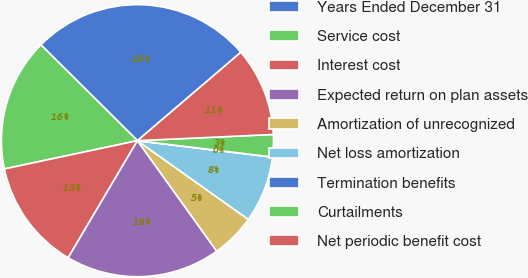Convert chart to OTSL. <chart><loc_0><loc_0><loc_500><loc_500><pie_chart><fcel>Years Ended December 31<fcel>Service cost<fcel>Interest cost<fcel>Expected return on plan assets<fcel>Amortization of unrecognized<fcel>Net loss amortization<fcel>Termination benefits<fcel>Curtailments<fcel>Net periodic benefit cost<nl><fcel>26.3%<fcel>15.78%<fcel>13.16%<fcel>18.41%<fcel>5.27%<fcel>7.9%<fcel>0.01%<fcel>2.64%<fcel>10.53%<nl></chart> 